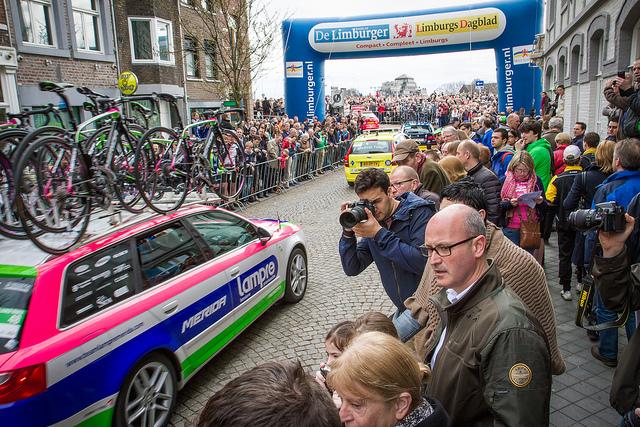Is the street cobblestone?
Write a very short answer. Yes. What is the man in the blue hoodie holding?
Keep it brief. Camera. What type of event is being held?
Keep it brief. Bicycle race. 